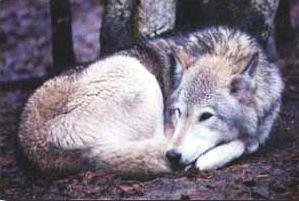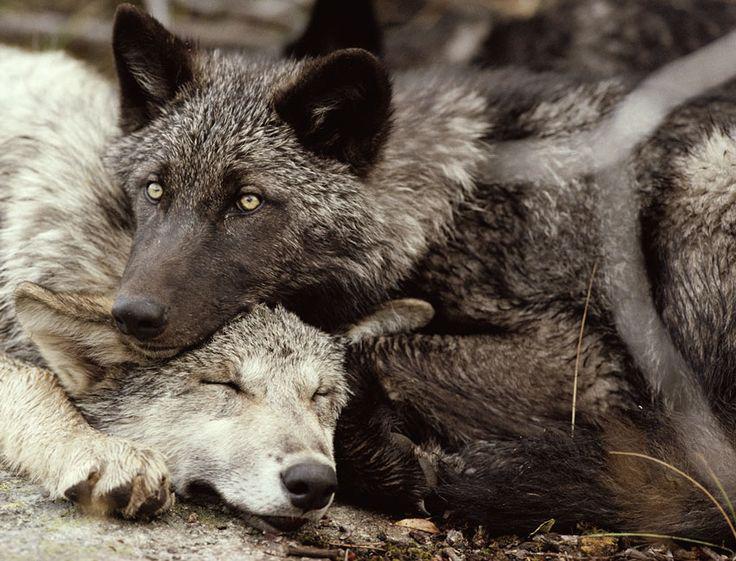The first image is the image on the left, the second image is the image on the right. Considering the images on both sides, is "One image contains two wolves standing up, and the other contains one wolf sleeping peacefully." valid? Answer yes or no. No. The first image is the image on the left, the second image is the image on the right. For the images displayed, is the sentence "One image shows two awake, open-eyed wolves posed close together and similarly." factually correct? Answer yes or no. No. 